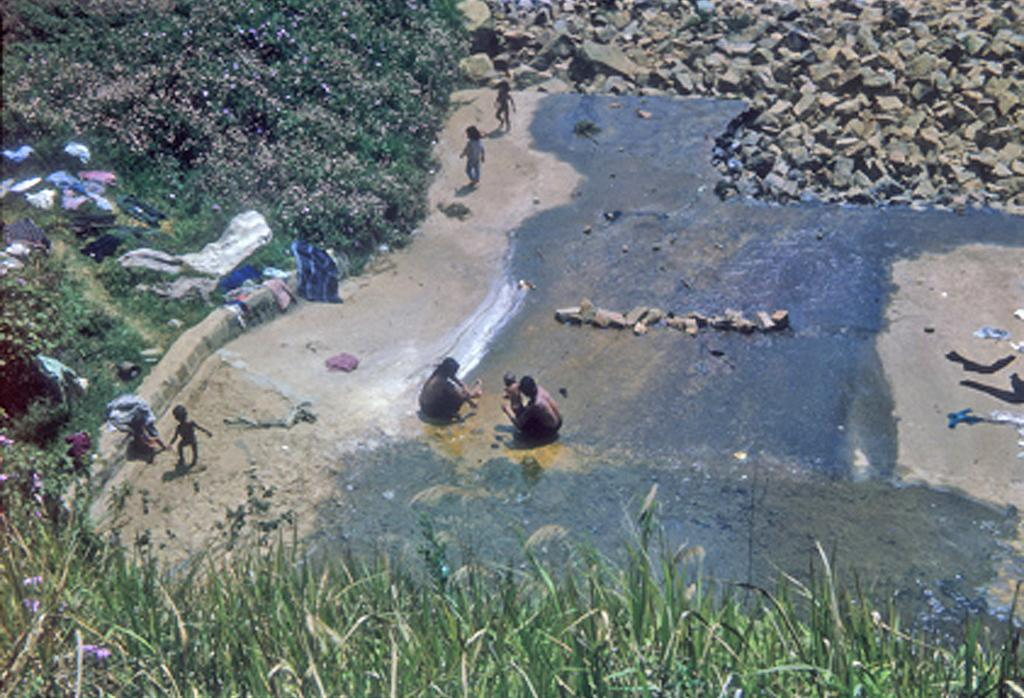What types of vegetation can be seen at the bottom of the image? There are plants and flowers at the bottom of the image. What can be seen in the background of the image? Water, people, additional plants and flowers, stones, and clothes are visible in the background of the image. What other objects can be seen in the background of the image? There are other objects in the background of the image. Where is the nest located in the image? There is no nest present in the image. What type of shoe can be seen in the image? There is no shoe present in the image. 